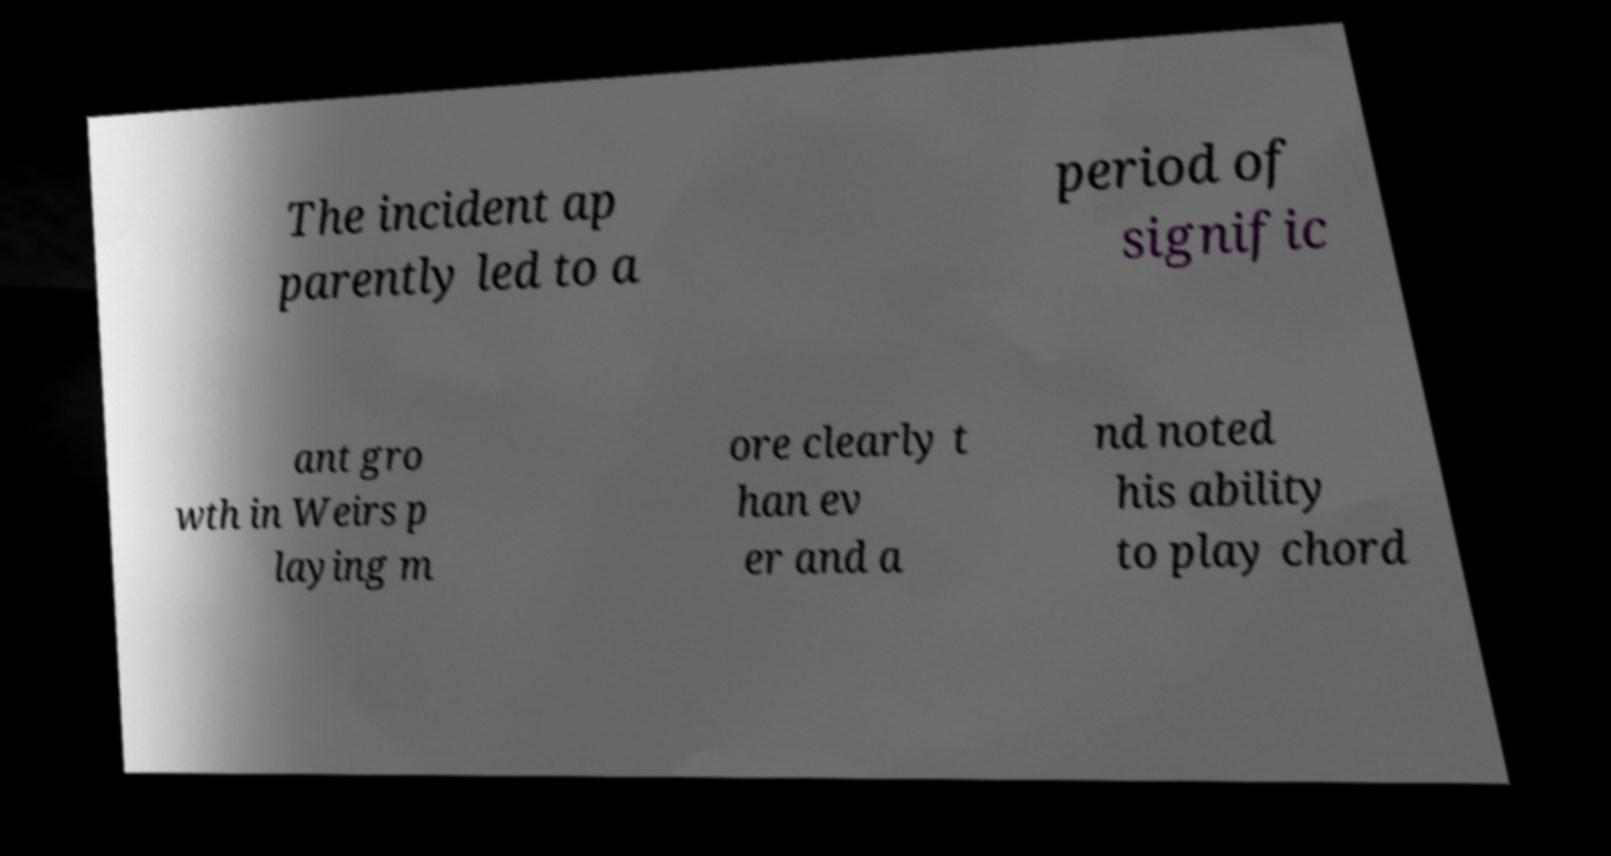Can you accurately transcribe the text from the provided image for me? The incident ap parently led to a period of signific ant gro wth in Weirs p laying m ore clearly t han ev er and a nd noted his ability to play chord 